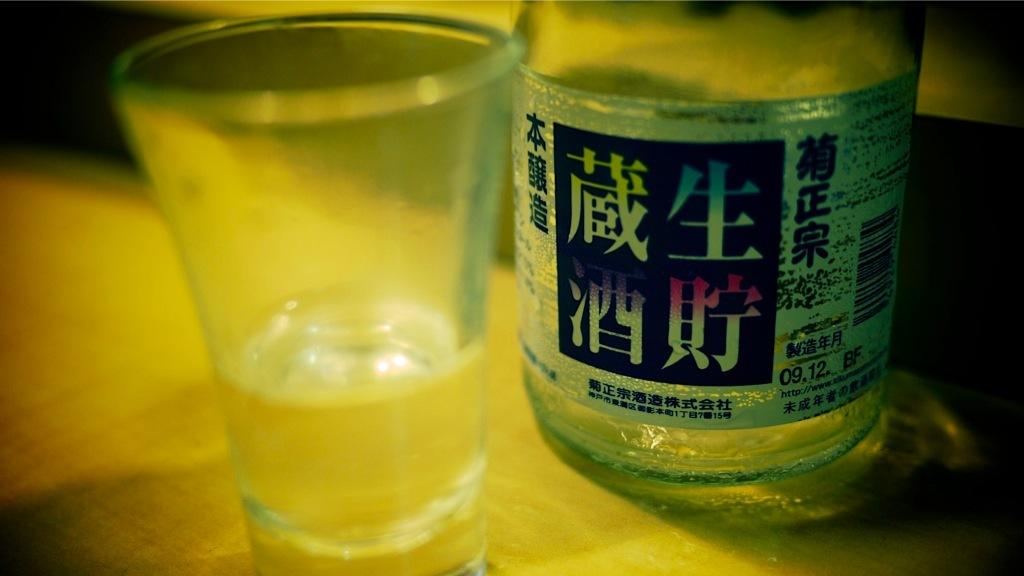<image>
Describe the image concisely. Plastic cup with clear liquid and a bottle that has 09.12. BF on it in black 